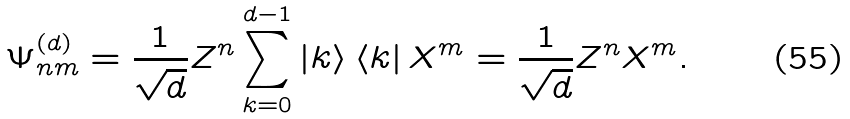Convert formula to latex. <formula><loc_0><loc_0><loc_500><loc_500>\Psi _ { n m } ^ { ( d ) } = \frac { 1 } { \sqrt { d } } Z ^ { n } \sum _ { k = 0 } ^ { d - 1 } \left | k \right \rangle \left \langle k \right | X ^ { m } = \frac { 1 } { \sqrt { d } } Z ^ { n } X ^ { m } .</formula> 